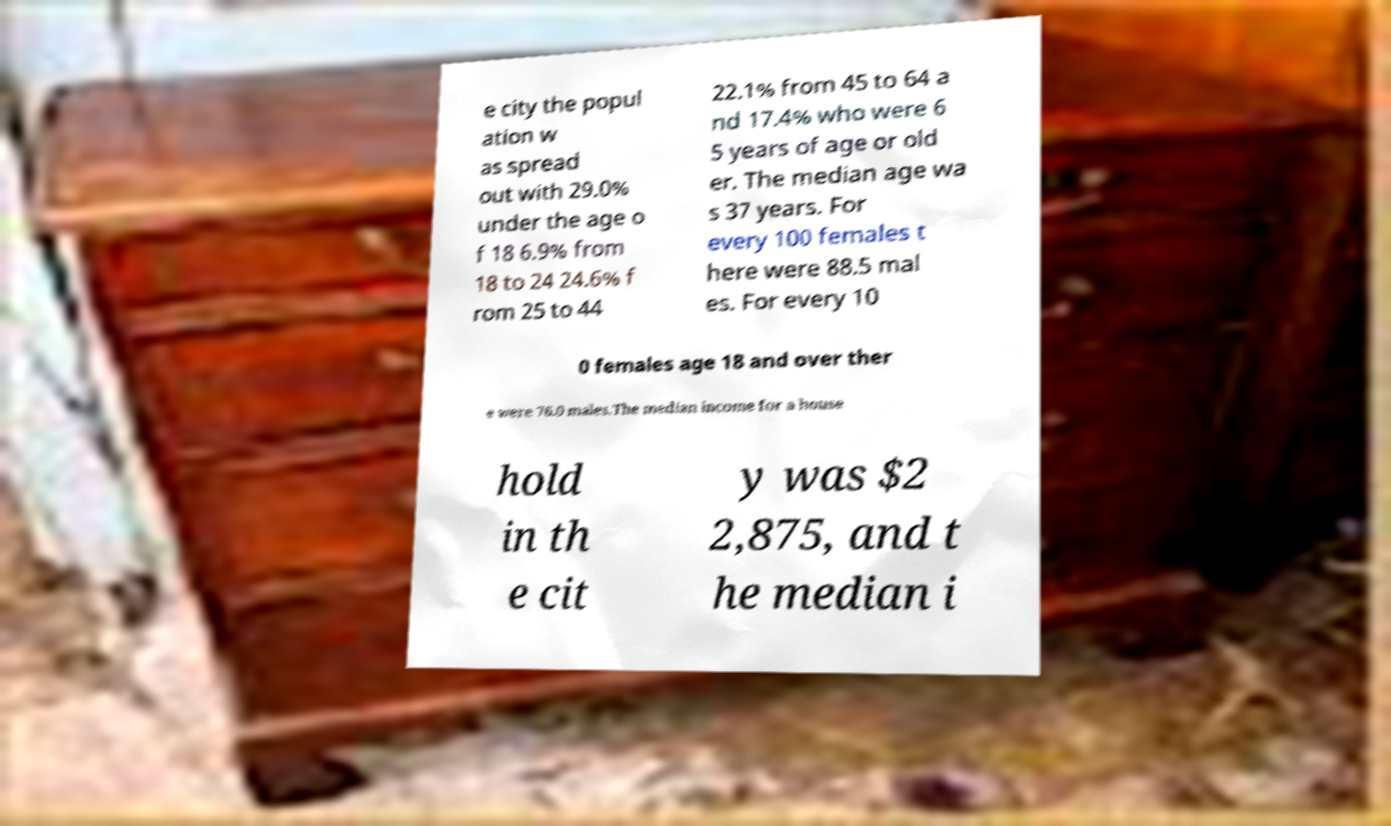For documentation purposes, I need the text within this image transcribed. Could you provide that? e city the popul ation w as spread out with 29.0% under the age o f 18 6.9% from 18 to 24 24.6% f rom 25 to 44 22.1% from 45 to 64 a nd 17.4% who were 6 5 years of age or old er. The median age wa s 37 years. For every 100 females t here were 88.5 mal es. For every 10 0 females age 18 and over ther e were 76.0 males.The median income for a house hold in th e cit y was $2 2,875, and t he median i 